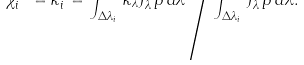<formula> <loc_0><loc_0><loc_500><loc_500>\chi _ { i } ^ { J \, \ast } = \kappa _ { i } ^ { J } = { \int _ { \Delta \lambda _ { i } } \, \kappa _ { \lambda } J _ { \lambda } ^ { p } p \, d \lambda } \, \Big / { \int _ { \Delta \lambda _ { i } } \, J _ { \lambda } ^ { p } p \, d \lambda } .</formula> 